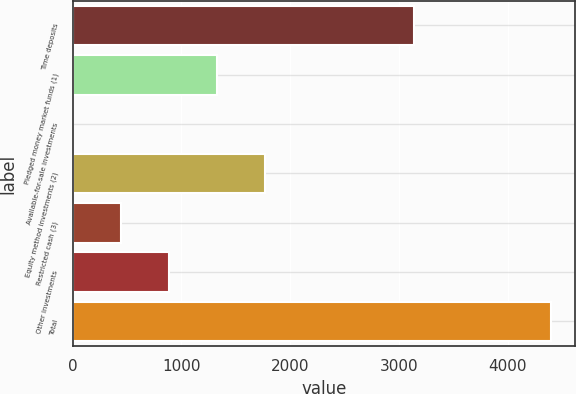Convert chart to OTSL. <chart><loc_0><loc_0><loc_500><loc_500><bar_chart><fcel>Time deposits<fcel>Pledged money market funds (1)<fcel>Available-for-sale investments<fcel>Equity method investments (2)<fcel>Restricted cash (3)<fcel>Other investments<fcel>Total<nl><fcel>3135<fcel>1325.4<fcel>9<fcel>1764.2<fcel>447.8<fcel>886.6<fcel>4397<nl></chart> 